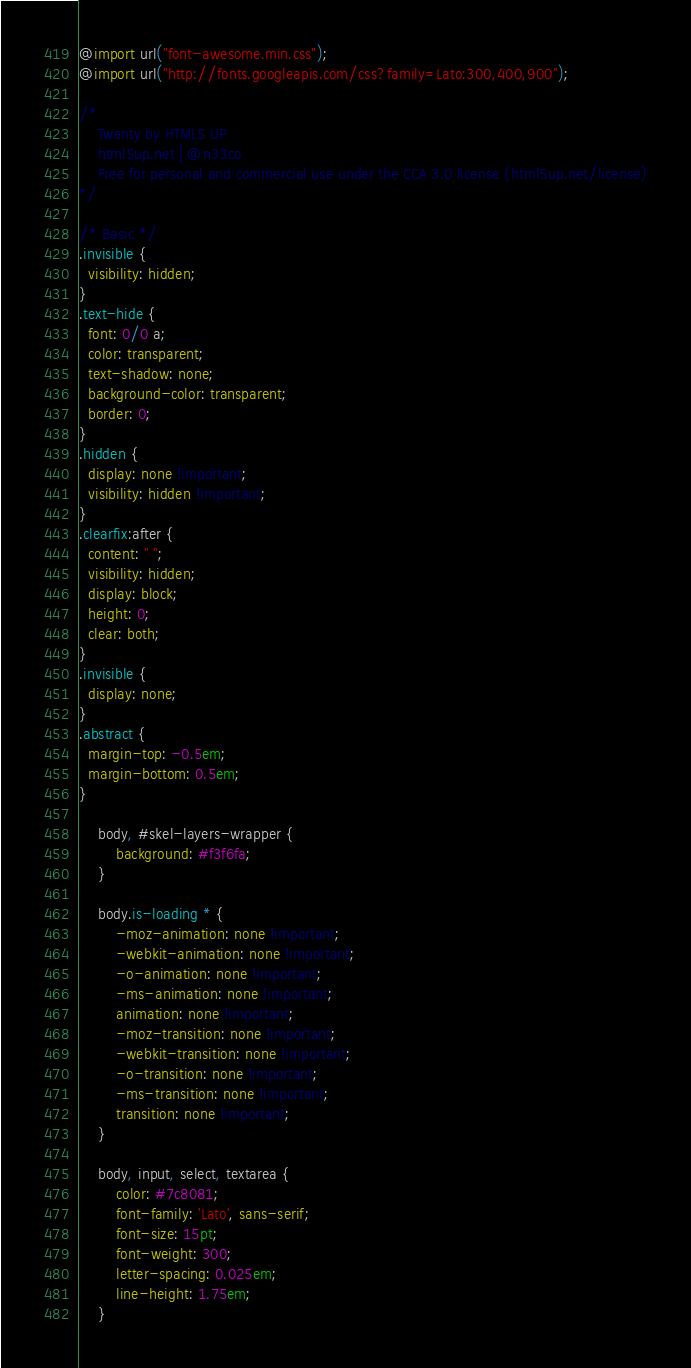<code> <loc_0><loc_0><loc_500><loc_500><_CSS_>@import url("font-awesome.min.css");
@import url("http://fonts.googleapis.com/css?family=Lato:300,400,900");

/*
	Twenty by HTML5 UP
	html5up.net | @n33co
	Free for personal and commercial use under the CCA 3.0 license (html5up.net/license)
*/

/* Basic */
.invisible {
  visibility: hidden;
}
.text-hide {
  font: 0/0 a;
  color: transparent;
  text-shadow: none;
  background-color: transparent;
  border: 0;
}
.hidden {
  display: none !important;
  visibility: hidden !important;
}
.clearfix:after {
  content: " ";
  visibility: hidden;
  display: block;
  height: 0;
  clear: both;
}
.invisible {
  display: none;
}
.abstract {
  margin-top: -0.5em;
  margin-bottom: 0.5em;
}

	body, #skel-layers-wrapper {
		background: #f3f6fa;
	}

	body.is-loading * {
		-moz-animation: none !important;
		-webkit-animation: none !important;
		-o-animation: none !important;
		-ms-animation: none !important;
		animation: none !important;
		-moz-transition: none !important;
		-webkit-transition: none !important;
		-o-transition: none !important;
		-ms-transition: none !important;
		transition: none !important;
	}

	body, input, select, textarea {
		color: #7c8081;
		font-family: 'Lato', sans-serif;
		font-size: 15pt;
		font-weight: 300;
		letter-spacing: 0.025em;
		line-height: 1.75em;
	}
</code> 